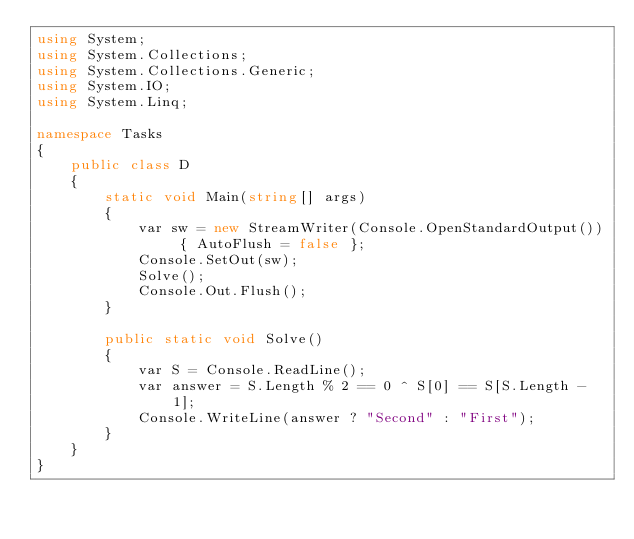Convert code to text. <code><loc_0><loc_0><loc_500><loc_500><_C#_>using System;
using System.Collections;
using System.Collections.Generic;
using System.IO;
using System.Linq;

namespace Tasks
{
    public class D
    {
        static void Main(string[] args)
        {
            var sw = new StreamWriter(Console.OpenStandardOutput()) { AutoFlush = false };
            Console.SetOut(sw);
            Solve();
            Console.Out.Flush();
        }

        public static void Solve()
        {
            var S = Console.ReadLine();
            var answer = S.Length % 2 == 0 ^ S[0] == S[S.Length - 1];
            Console.WriteLine(answer ? "Second" : "First");
        }
    }
}
</code> 